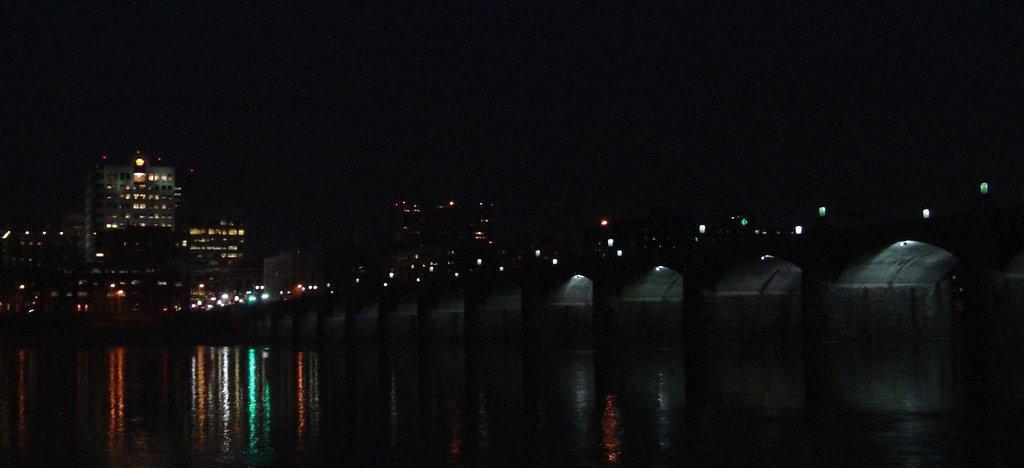Please provide a concise description of this image. In this image I can see the water. In the background I can see few lights and buildings and the sky is in black color. 